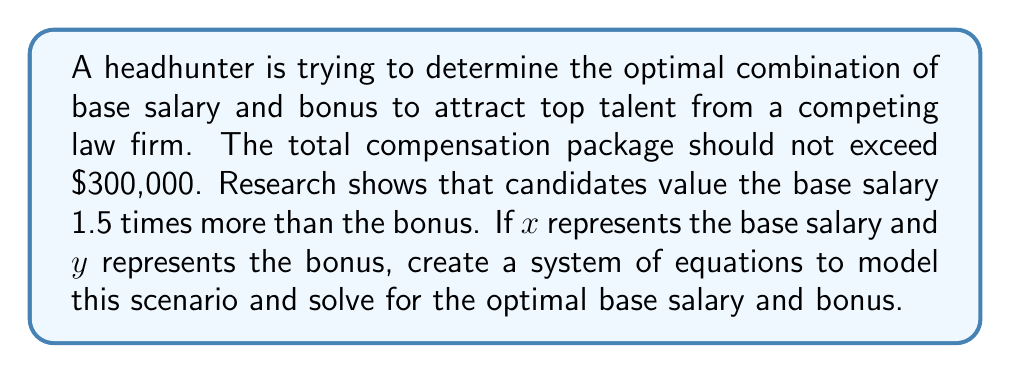Teach me how to tackle this problem. To solve this problem, we need to create a system of two equations based on the given information:

1. The total compensation package should not exceed $300,000:
   $$x + y = 300000$$

2. Candidates value the base salary 1.5 times more than the bonus:
   $$1.5y = x$$

Now we have a system of two equations with two unknowns:

$$\begin{cases}
x + y = 300000 \\
1.5y = x
\end{cases}$$

Let's solve this system using substitution:

1. From the second equation, we can express $x$ in terms of $y$:
   $$x = 1.5y$$

2. Substitute this expression into the first equation:
   $$1.5y + y = 300000$$
   $$2.5y = 300000$$

3. Solve for $y$:
   $$y = \frac{300000}{2.5} = 120000$$

4. Now that we know $y$, we can find $x$ using either of the original equations. Let's use the second one:
   $$x = 1.5y = 1.5 \times 120000 = 180000$$

Therefore, the optimal combination is a base salary of $180,000 and a bonus of $120,000.
Answer: The optimal combination to attract top talent is a base salary of $180,000 and a bonus of $120,000. 